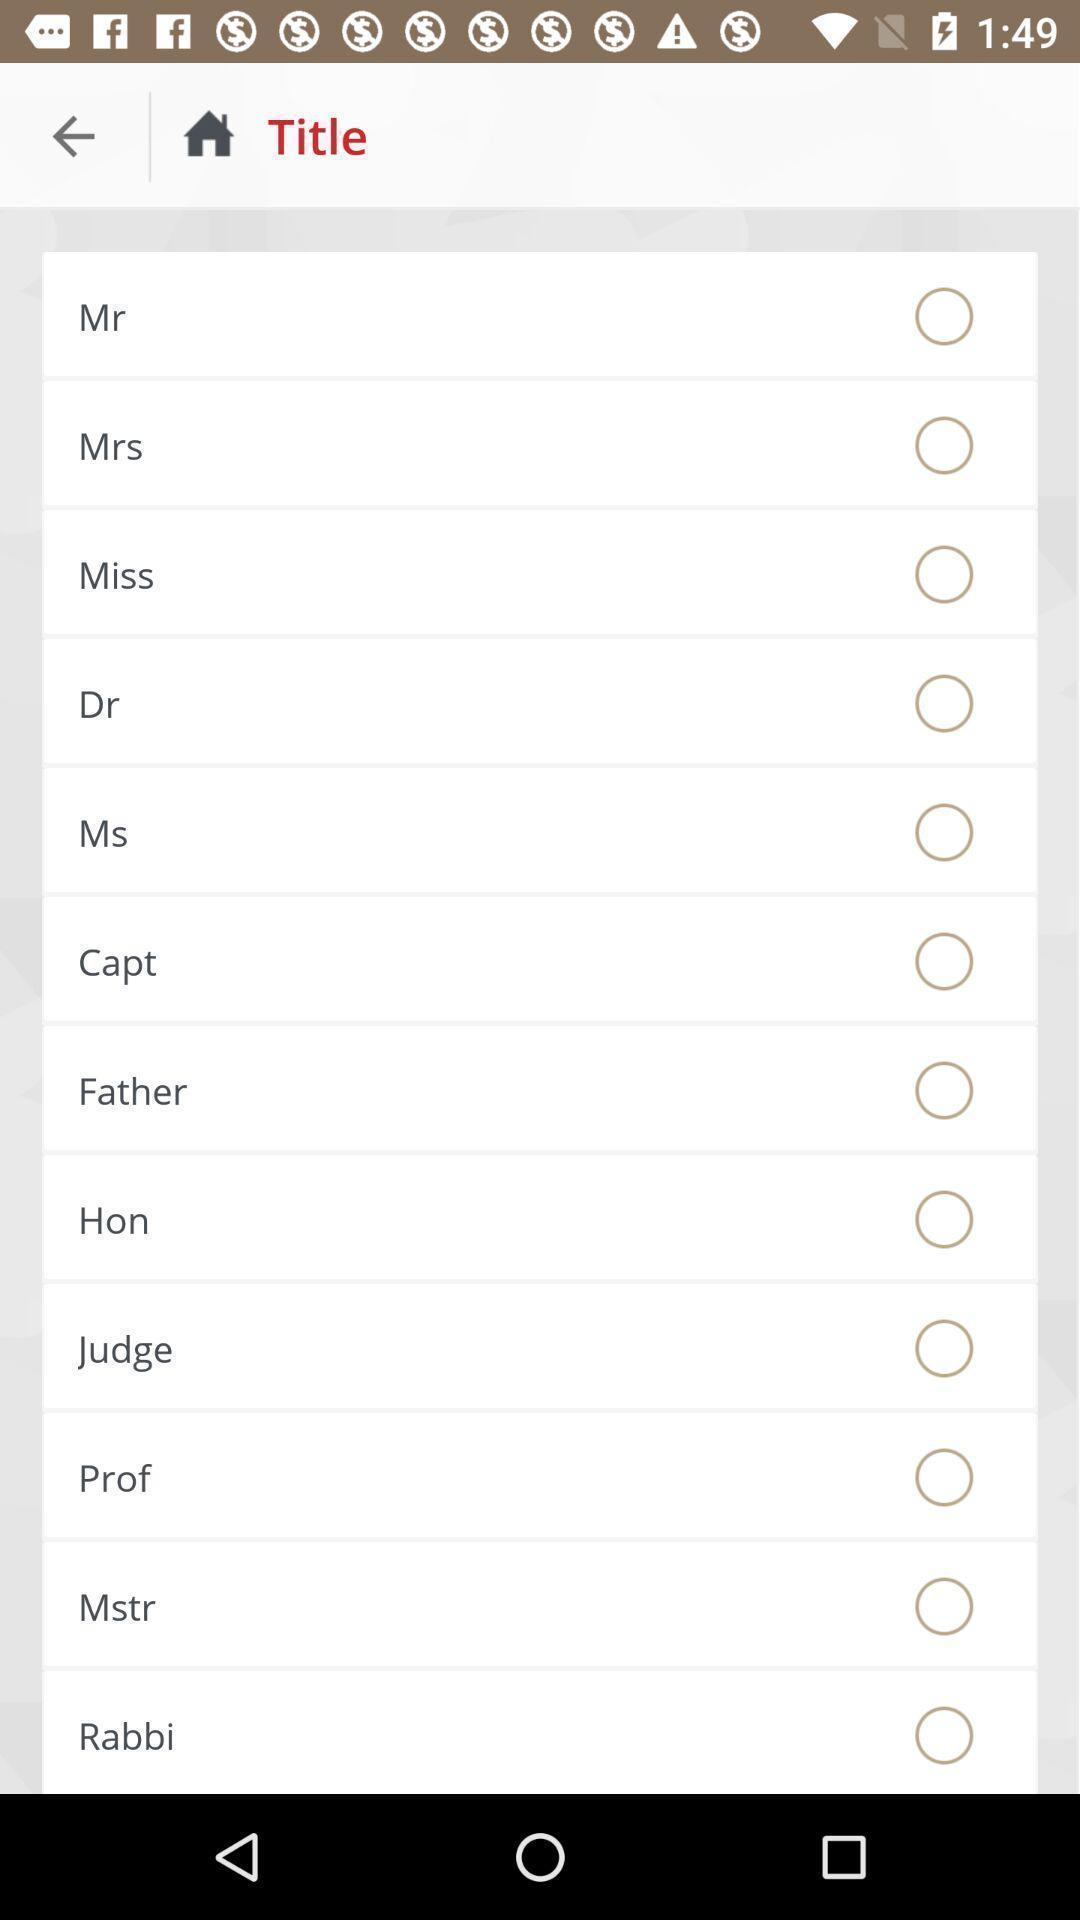What is the overall content of this screenshot? Screen displaying multiple title options. 